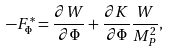<formula> <loc_0><loc_0><loc_500><loc_500>- F _ { \Phi } ^ { * } = \frac { \partial W } { \partial \Phi } + \frac { \partial K } { \partial \Phi } \frac { W } { M _ { P } ^ { 2 } } ,</formula> 